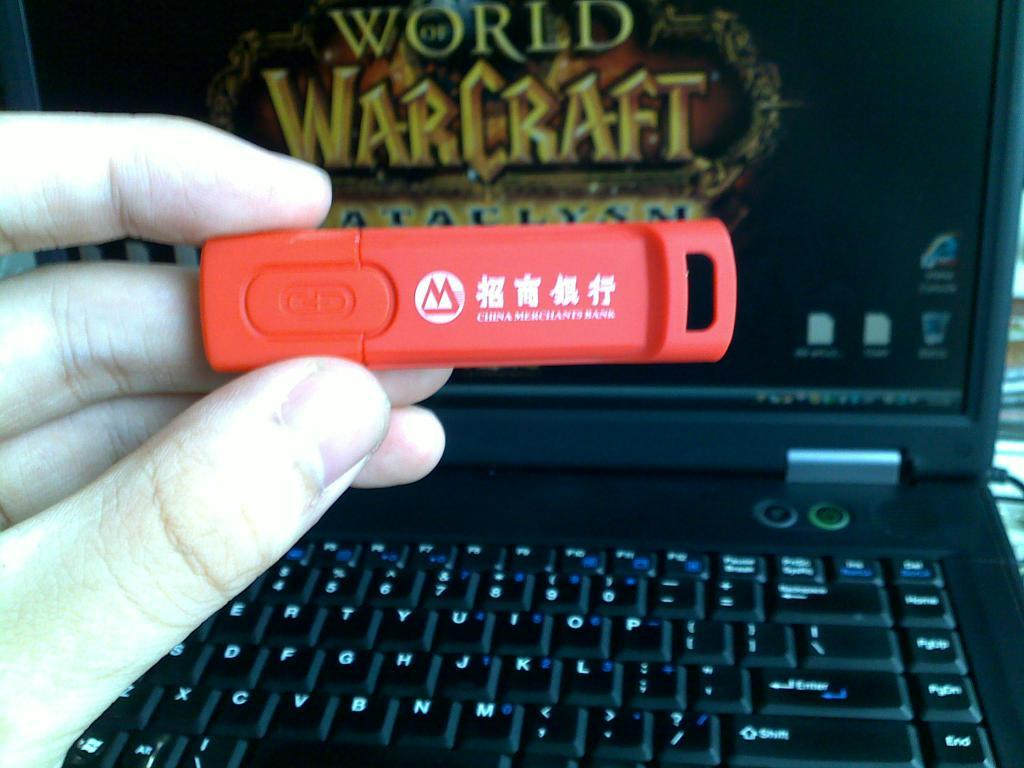<image>
Render a clear and concise summary of the photo. A red flashdrive in front of a black laptop with world warcraf 